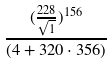<formula> <loc_0><loc_0><loc_500><loc_500>\frac { ( \frac { 2 2 8 } { \sqrt { 1 } } ) ^ { 1 5 6 } } { ( 4 + 3 2 0 \cdot 3 5 6 ) }</formula> 